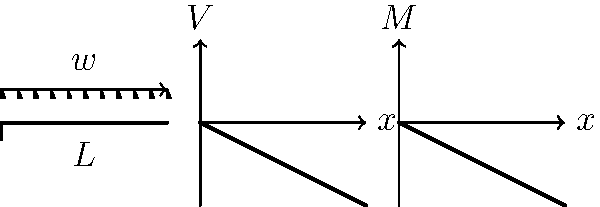As a civil engineer overseeing infrastructure projects in Tamil Nadu, you're analyzing a cantilever beam supporting a uniformly distributed load of $w$ kN/m over its entire length $L$. Draw the shear force and bending moment diagrams for this beam. What are the maximum shear force and bending moment values, and where do they occur? Let's analyze this step-by-step:

1) For a cantilever beam with a uniformly distributed load:
   - The free end is on the right
   - The fixed end is on the left

2) Shear Force (V) Diagram:
   - At the free end (x = L), V = 0
   - At the fixed end (x = 0), V = -wL
   - The shear force varies linearly from -wL to 0

3) Bending Moment (M) Diagram:
   - At the free end (x = L), M = 0
   - At the fixed end (x = 0), M = -wL²/2
   - The bending moment varies parabolically from -wL²/2 to 0

4) Maximum Shear Force:
   - Occurs at the fixed end (x = 0)
   - V_max = |-wL|

5) Maximum Bending Moment:
   - Also occurs at the fixed end (x = 0)
   - M_max = |-wL²/2|

These diagrams highlight the structural challenges we face in Tamil Nadu's infrastructure projects, especially in coastal areas where cantilever structures are common in bridges and buildings.
Answer: Maximum shear force: $wL$ at fixed end. Maximum bending moment: $wL²/2$ at fixed end. 